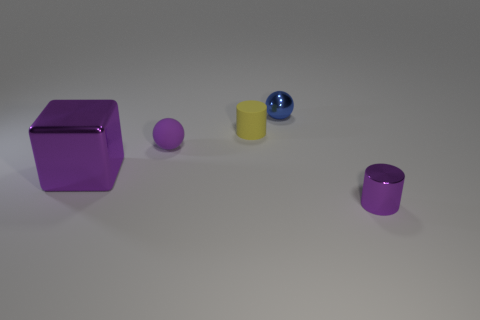How might the arrangement of these objects reflect principles of visual design? The arrangement of the objects in the image provides an interesting exploration of balance and color. The largest purple cube on the left appears to counterbalance the smaller objects arranged progressively to the right, creating a sense of stability. The primary colors, purple and yellow, are complementary, which adds visual interest and harmonizes the scene. The blue sphere adds depth and contrast, highlighting the principle of color dynamics in visual design. 